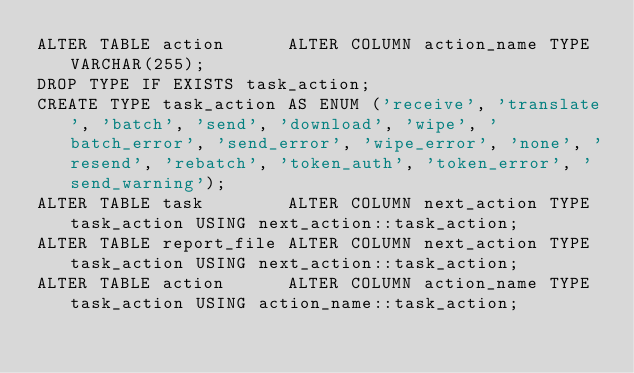Convert code to text. <code><loc_0><loc_0><loc_500><loc_500><_SQL_>ALTER TABLE action      ALTER COLUMN action_name TYPE VARCHAR(255);
DROP TYPE IF EXISTS task_action;
CREATE TYPE task_action AS ENUM ('receive', 'translate', 'batch', 'send', 'download', 'wipe', 'batch_error', 'send_error', 'wipe_error', 'none', 'resend', 'rebatch', 'token_auth', 'token_error', 'send_warning');
ALTER TABLE task        ALTER COLUMN next_action TYPE task_action USING next_action::task_action;
ALTER TABLE report_file ALTER COLUMN next_action TYPE task_action USING next_action::task_action;
ALTER TABLE action      ALTER COLUMN action_name TYPE task_action USING action_name::task_action;</code> 